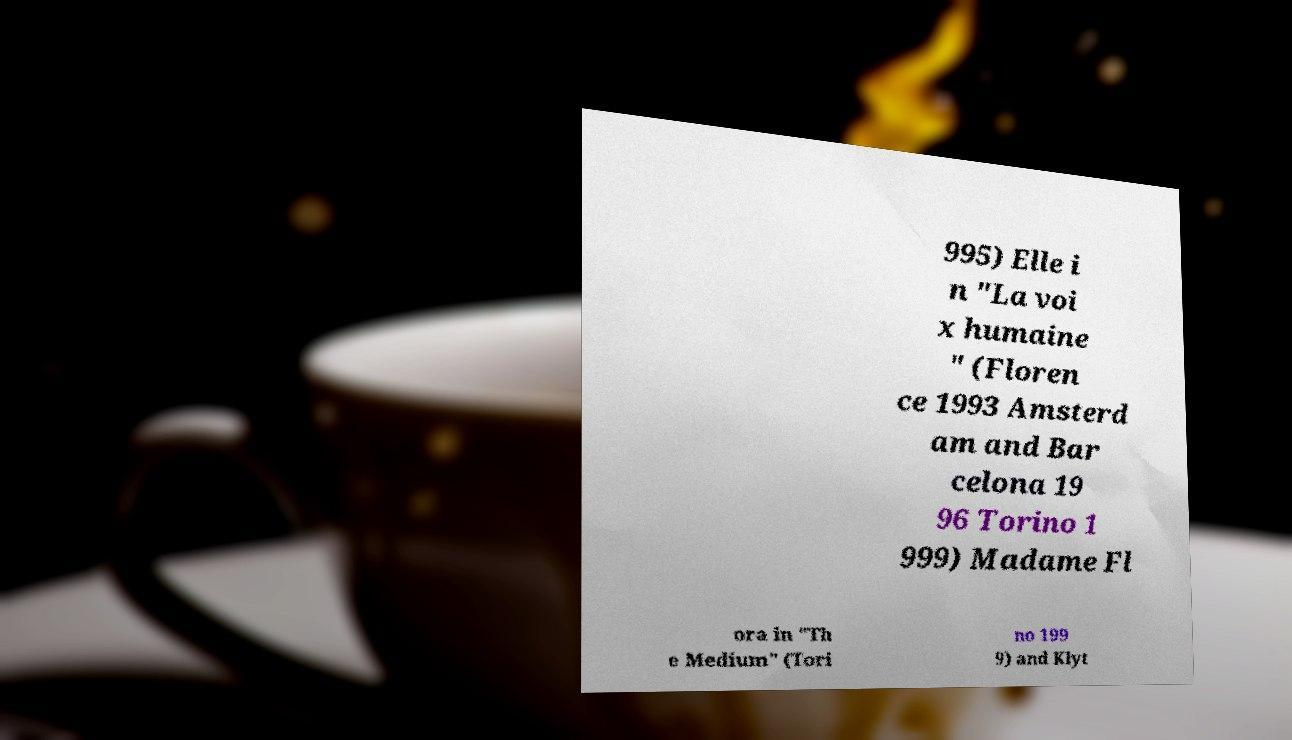For documentation purposes, I need the text within this image transcribed. Could you provide that? 995) Elle i n "La voi x humaine " (Floren ce 1993 Amsterd am and Bar celona 19 96 Torino 1 999) Madame Fl ora in "Th e Medium" (Tori no 199 9) and Klyt 